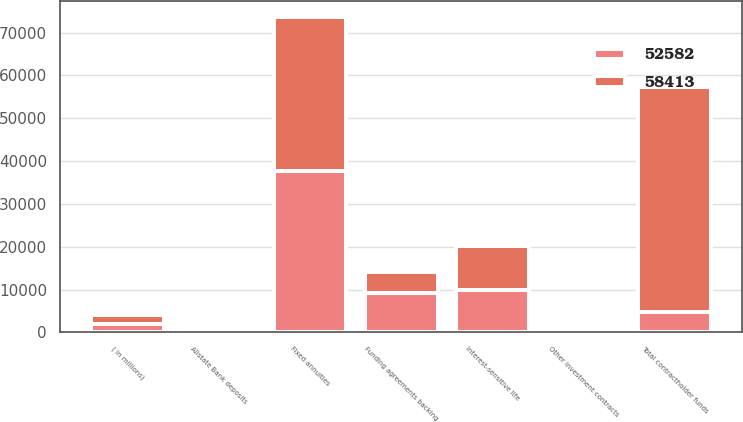Convert chart. <chart><loc_0><loc_0><loc_500><loc_500><stacked_bar_chart><ecel><fcel>( in millions)<fcel>Interest-sensitive life<fcel>Fixed annuities<fcel>Funding agreements backing<fcel>Other investment contracts<fcel>Allstate Bank deposits<fcel>Total contractholder funds<nl><fcel>58413<fcel>2009<fcel>10276<fcel>36063<fcel>4699<fcel>459<fcel>1085<fcel>52582<nl><fcel>52582<fcel>2008<fcel>9957<fcel>37660<fcel>9314<fcel>533<fcel>949<fcel>4699<nl></chart> 